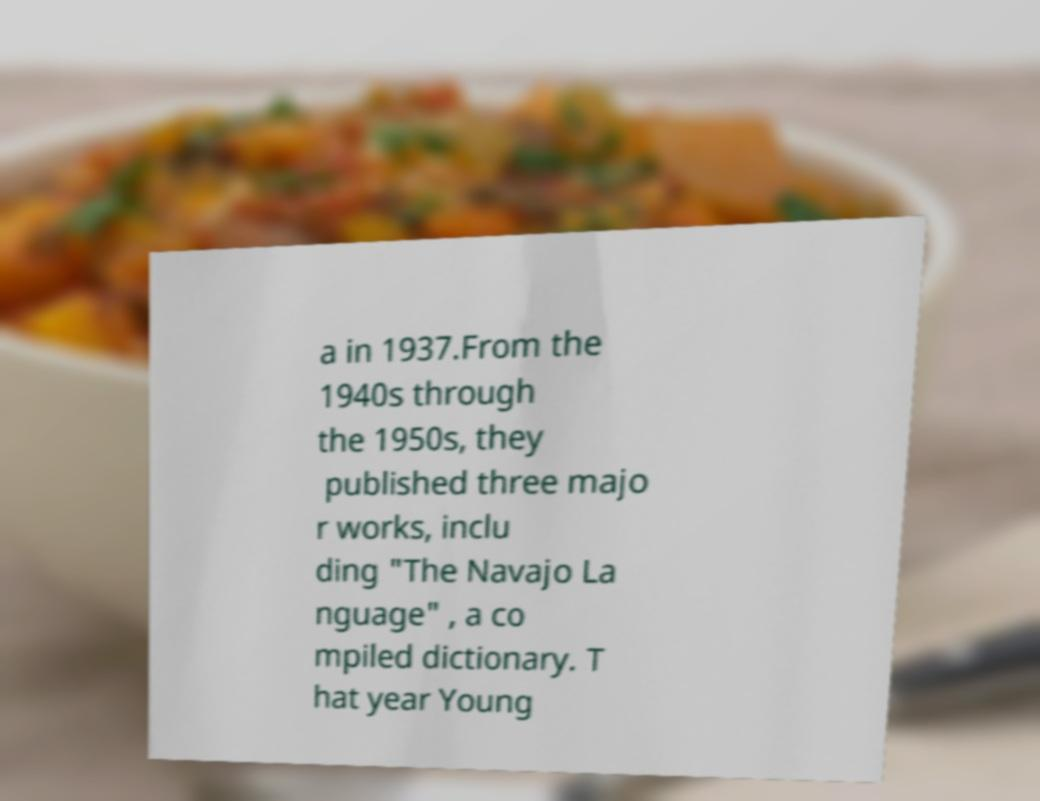Can you read and provide the text displayed in the image?This photo seems to have some interesting text. Can you extract and type it out for me? a in 1937.From the 1940s through the 1950s, they published three majo r works, inclu ding "The Navajo La nguage" , a co mpiled dictionary. T hat year Young 